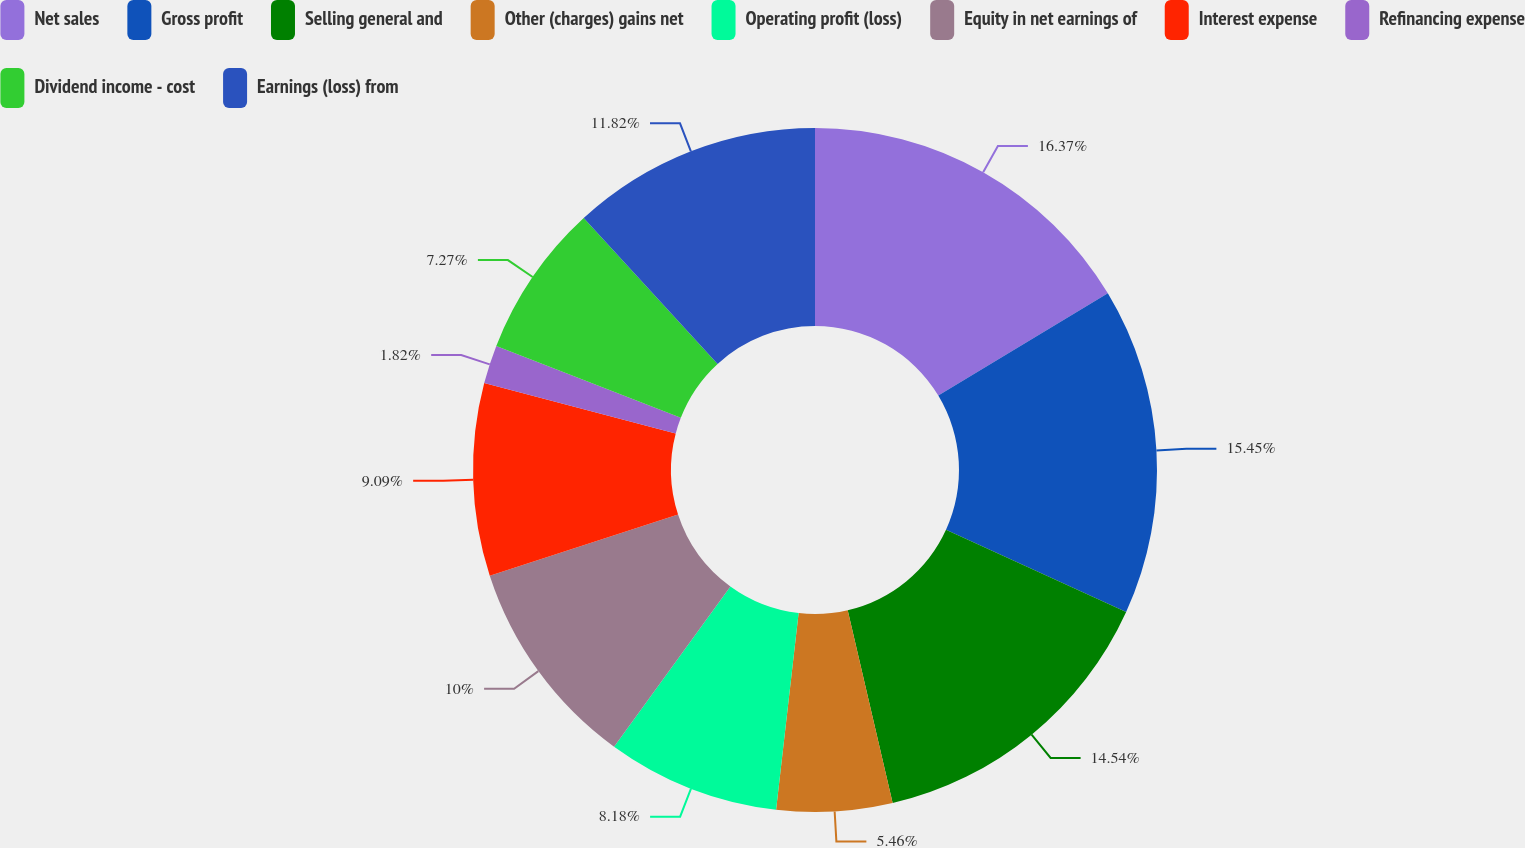Convert chart. <chart><loc_0><loc_0><loc_500><loc_500><pie_chart><fcel>Net sales<fcel>Gross profit<fcel>Selling general and<fcel>Other (charges) gains net<fcel>Operating profit (loss)<fcel>Equity in net earnings of<fcel>Interest expense<fcel>Refinancing expense<fcel>Dividend income - cost<fcel>Earnings (loss) from<nl><fcel>16.36%<fcel>15.45%<fcel>14.54%<fcel>5.46%<fcel>8.18%<fcel>10.0%<fcel>9.09%<fcel>1.82%<fcel>7.27%<fcel>11.82%<nl></chart> 